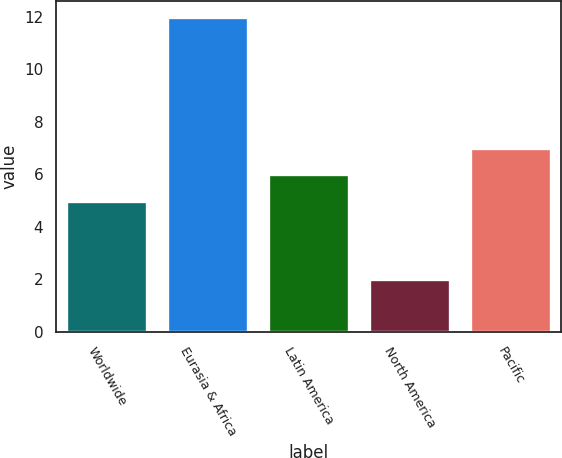<chart> <loc_0><loc_0><loc_500><loc_500><bar_chart><fcel>Worldwide<fcel>Eurasia & Africa<fcel>Latin America<fcel>North America<fcel>Pacific<nl><fcel>5<fcel>12<fcel>6<fcel>2<fcel>7<nl></chart> 